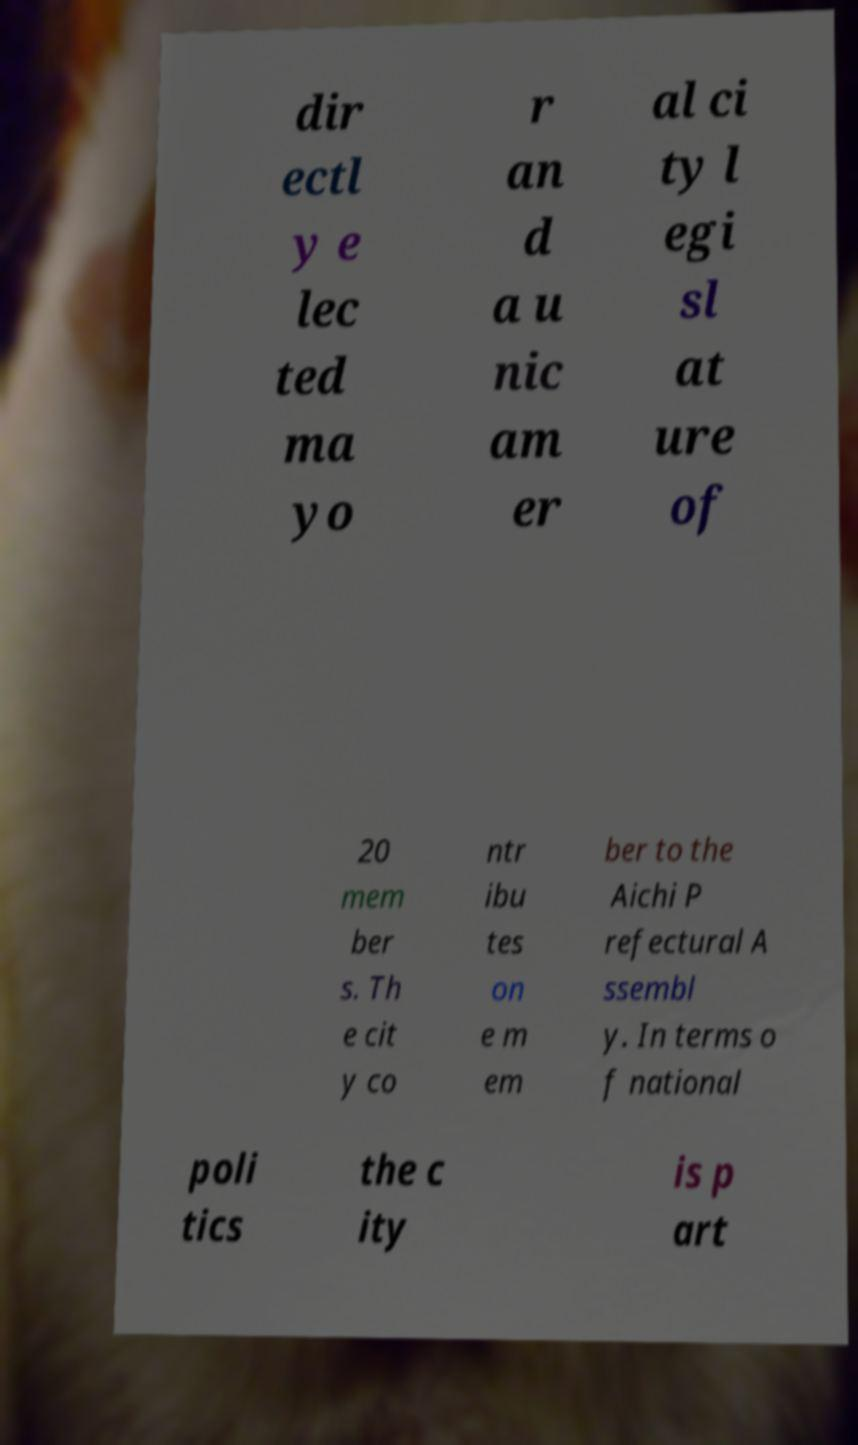Please read and relay the text visible in this image. What does it say? dir ectl y e lec ted ma yo r an d a u nic am er al ci ty l egi sl at ure of 20 mem ber s. Th e cit y co ntr ibu tes on e m em ber to the Aichi P refectural A ssembl y. In terms o f national poli tics the c ity is p art 